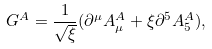Convert formula to latex. <formula><loc_0><loc_0><loc_500><loc_500>G ^ { A } = \frac { 1 } { \sqrt { \xi } } ( \partial ^ { \mu } A _ { \mu } ^ { A } + \xi \partial ^ { 5 } A _ { 5 } ^ { A } ) ,</formula> 